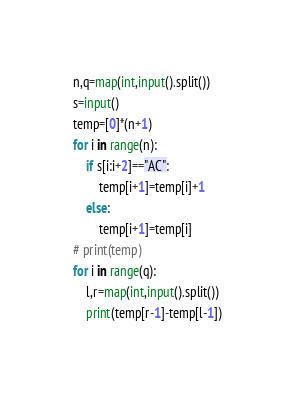<code> <loc_0><loc_0><loc_500><loc_500><_Python_>n,q=map(int,input().split())
s=input()
temp=[0]*(n+1)
for i in range(n):
	if s[i:i+2]=="AC":
		temp[i+1]=temp[i]+1
	else:
		temp[i+1]=temp[i]
# print(temp)
for i in range(q):
	l,r=map(int,input().split())
	print(temp[r-1]-temp[l-1])</code> 